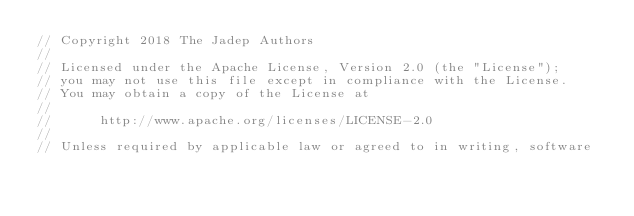<code> <loc_0><loc_0><loc_500><loc_500><_Go_>// Copyright 2018 The Jadep Authors
//
// Licensed under the Apache License, Version 2.0 (the "License");
// you may not use this file except in compliance with the License.
// You may obtain a copy of the License at
//
//      http://www.apache.org/licenses/LICENSE-2.0
//
// Unless required by applicable law or agreed to in writing, software</code> 